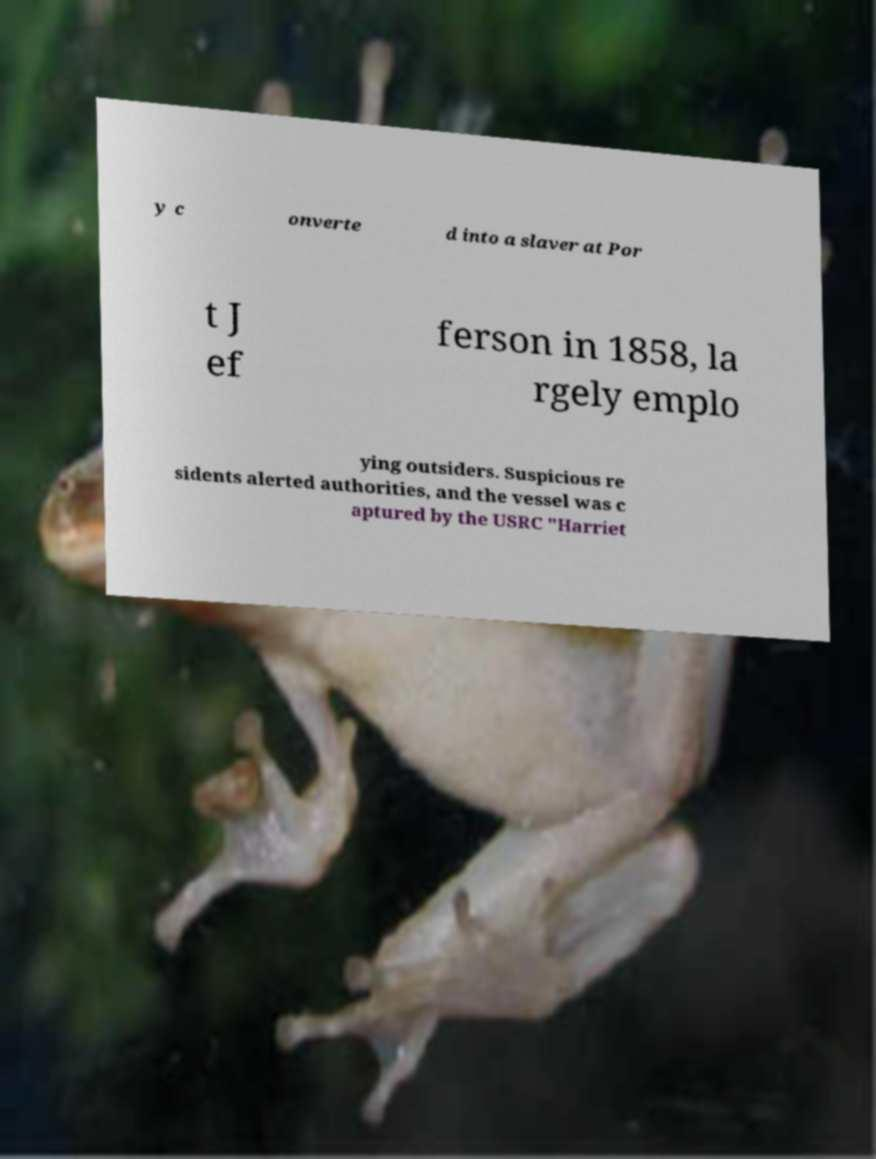What messages or text are displayed in this image? I need them in a readable, typed format. y c onverte d into a slaver at Por t J ef ferson in 1858, la rgely emplo ying outsiders. Suspicious re sidents alerted authorities, and the vessel was c aptured by the USRC "Harriet 